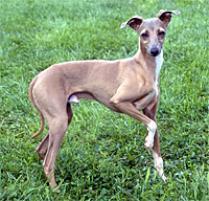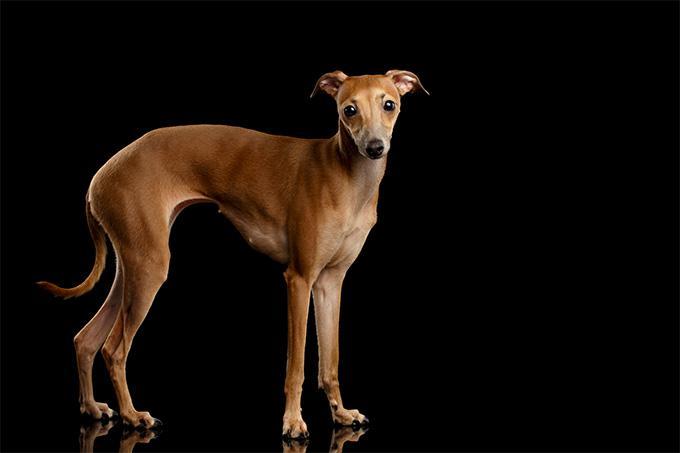The first image is the image on the left, the second image is the image on the right. For the images displayed, is the sentence "At least one image shows a grey dog wearing a color." factually correct? Answer yes or no. No. 